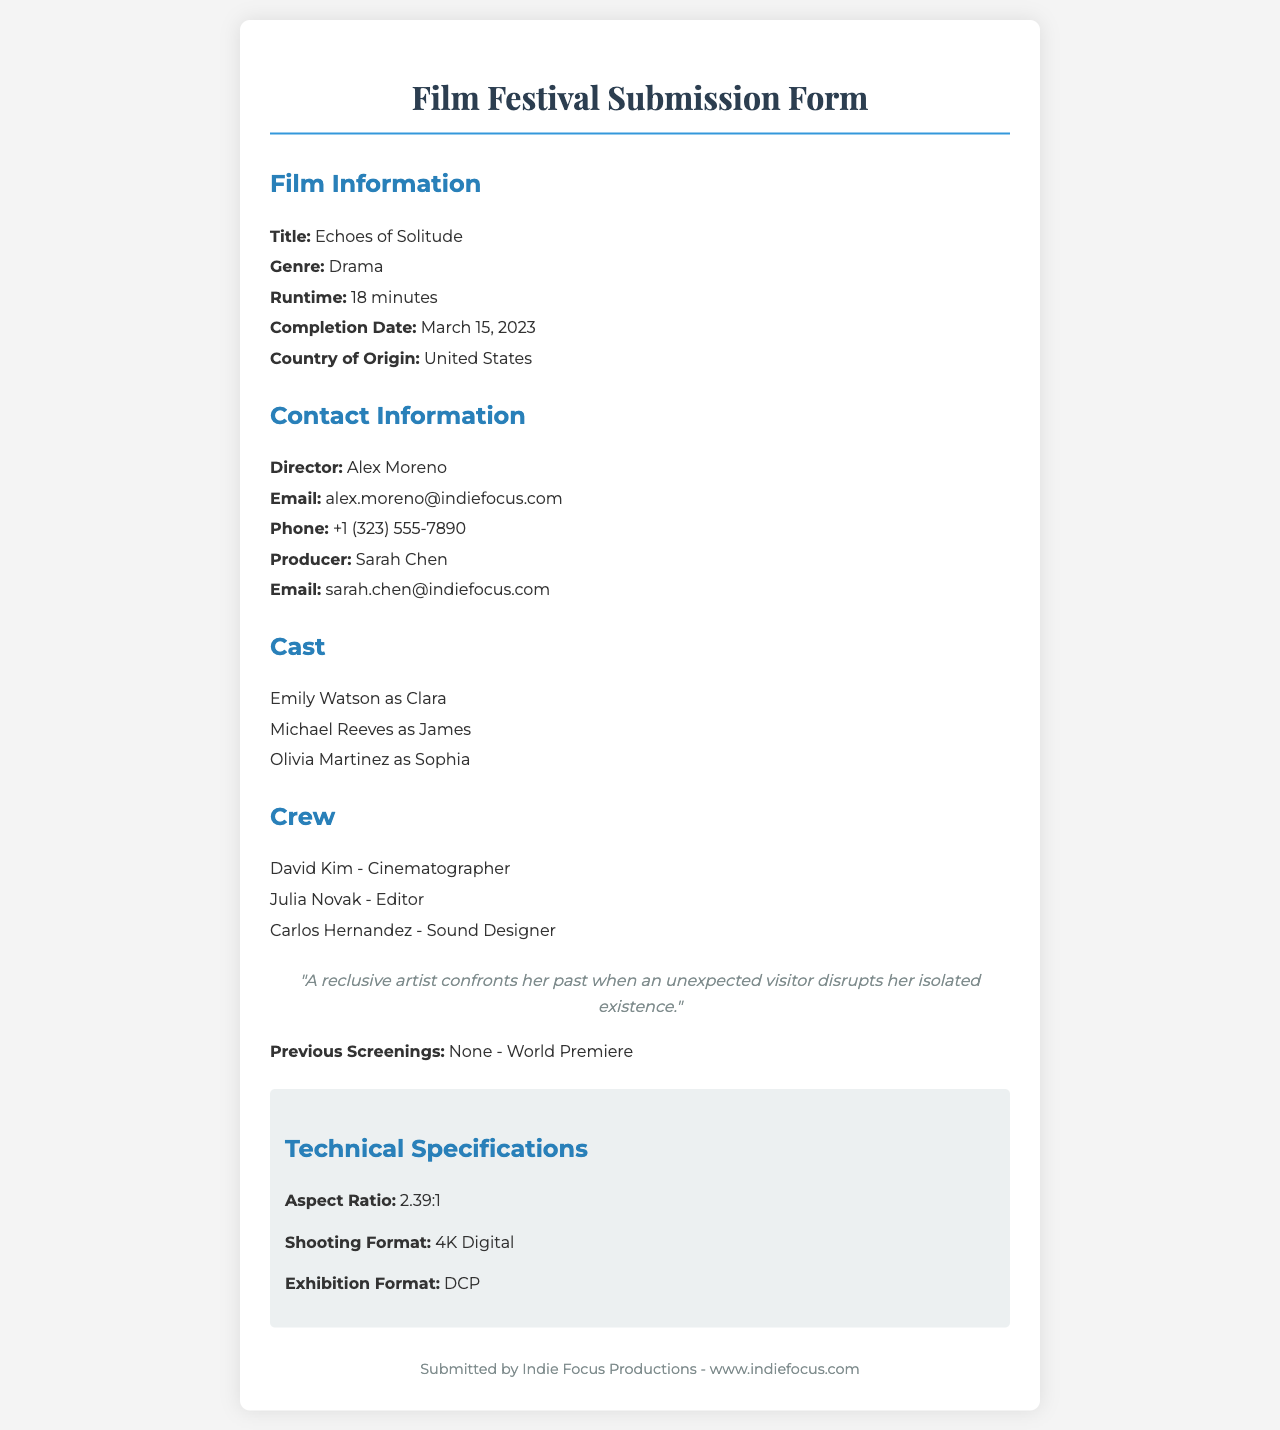what is the title of the film? The title of the film is found in the Film Information section of the document.
Answer: Echoes of Solitude who is the director of the film? The director's name is mentioned in the Contact Information section.
Answer: Alex Moreno how long is the film's runtime? The runtime is specified in the Film Information section.
Answer: 18 minutes what is the aspect ratio of the film? The aspect ratio is found in the Technical Specifications section.
Answer: 2.39:1 who plays the character Clara? The cast information lists the actors and their respective roles.
Answer: Emily Watson when was the film completed? The completion date is outlined in the Film Information section.
Answer: March 15, 2023 what is the country of origin for the film? The country of origin is specified in the Film Information section.
Answer: United States who is the producer of the film? The producer's name is listed in the Contact Information section.
Answer: Sarah Chen has the film had any previous screenings? This information is provided in the Additional Info section of the document.
Answer: None - World Premiere 